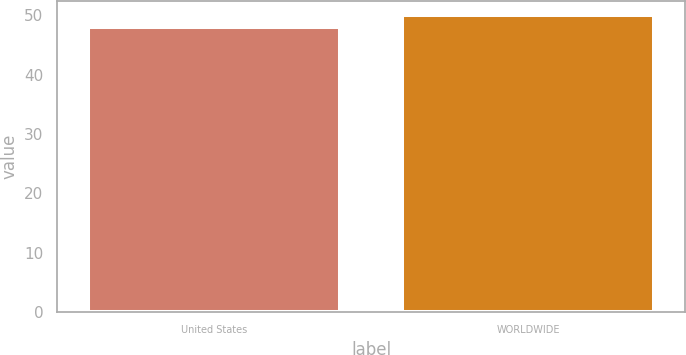Convert chart to OTSL. <chart><loc_0><loc_0><loc_500><loc_500><bar_chart><fcel>United States<fcel>WORLDWIDE<nl><fcel>48<fcel>50<nl></chart> 